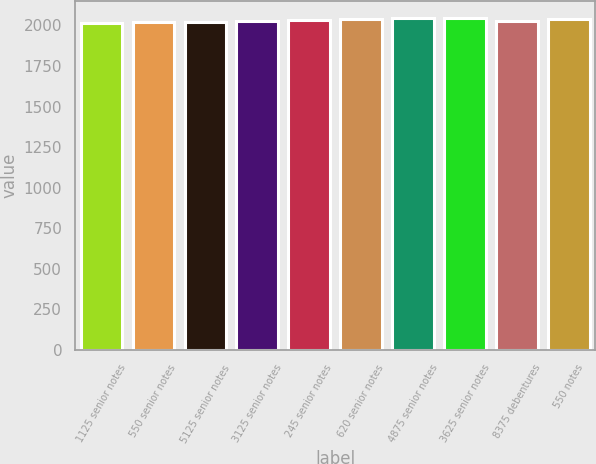Convert chart to OTSL. <chart><loc_0><loc_0><loc_500><loc_500><bar_chart><fcel>1125 senior notes<fcel>550 senior notes<fcel>5125 senior notes<fcel>3125 senior notes<fcel>245 senior notes<fcel>620 senior notes<fcel>4875 senior notes<fcel>3625 senior notes<fcel>8375 debentures<fcel>550 notes<nl><fcel>2017<fcel>2020.3<fcel>2023.6<fcel>2030.2<fcel>2033.5<fcel>2040.1<fcel>2043.4<fcel>2046.7<fcel>2026.9<fcel>2036.8<nl></chart> 